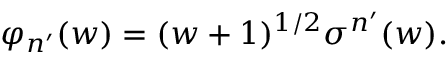<formula> <loc_0><loc_0><loc_500><loc_500>\varphi _ { n ^ { \prime } } ( w ) = ( w + 1 ) ^ { 1 / 2 } \sigma ^ { n ^ { \prime } } ( w ) .</formula> 